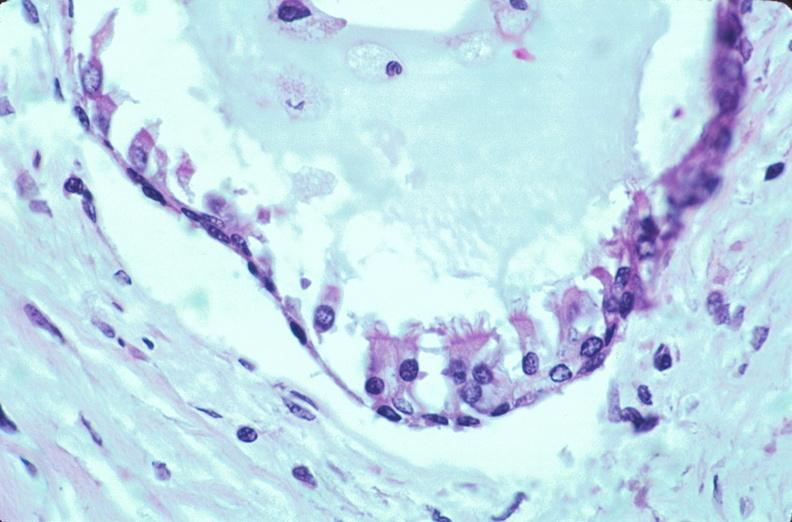what does this image show?
Answer the question using a single word or phrase. Pharyngeal pouch remnant 